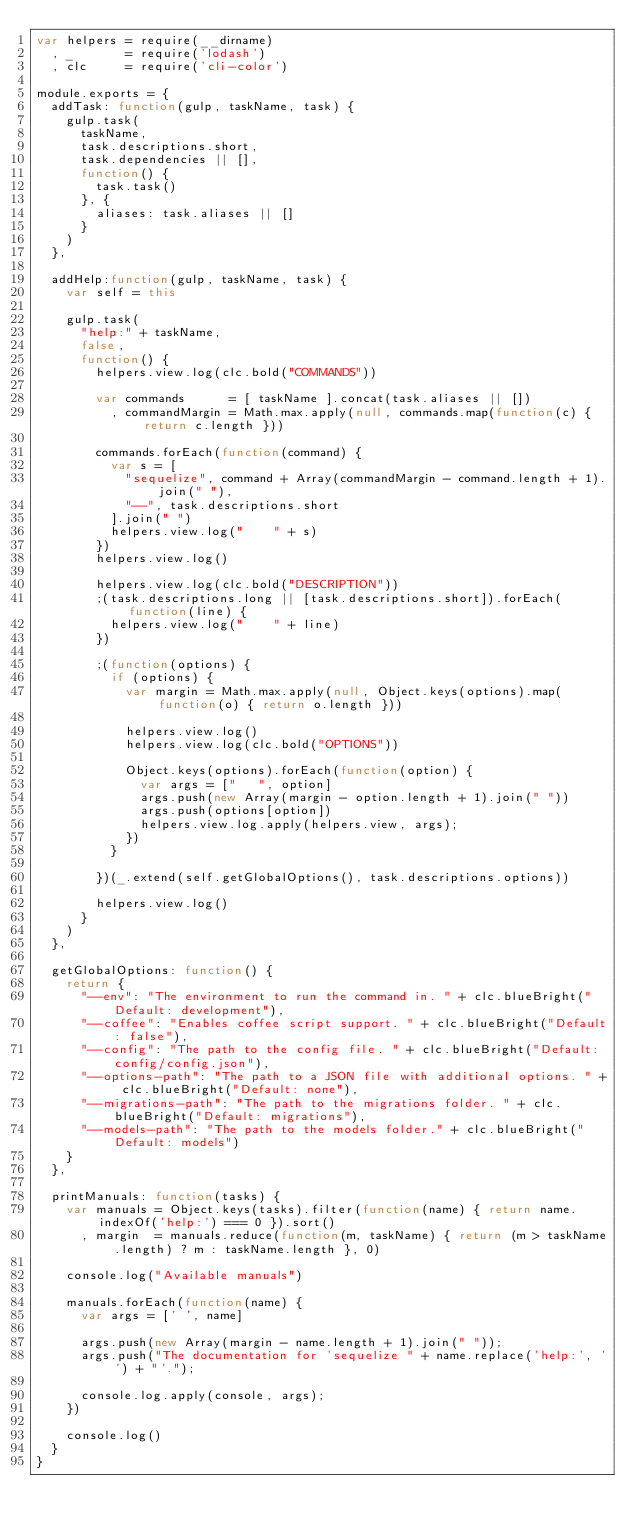Convert code to text. <code><loc_0><loc_0><loc_500><loc_500><_JavaScript_>var helpers = require(__dirname)
  , _       = require('lodash')
  , clc     = require('cli-color')

module.exports = {
  addTask: function(gulp, taskName, task) {
    gulp.task(
      taskName,
      task.descriptions.short,
      task.dependencies || [],
      function() {
        task.task()
      }, {
        aliases: task.aliases || []
      }
    )
  },

  addHelp:function(gulp, taskName, task) {
    var self = this

    gulp.task(
      "help:" + taskName,
      false,
      function() {
        helpers.view.log(clc.bold("COMMANDS"))

        var commands      = [ taskName ].concat(task.aliases || [])
          , commandMargin = Math.max.apply(null, commands.map(function(c) { return c.length }))

        commands.forEach(function(command) {
          var s = [
            "sequelize", command + Array(commandMargin - command.length + 1).join(" "),
            "--", task.descriptions.short
          ].join(" ")
          helpers.view.log("    " + s)
        })
        helpers.view.log()

        helpers.view.log(clc.bold("DESCRIPTION"))
        ;(task.descriptions.long || [task.descriptions.short]).forEach(function(line) {
          helpers.view.log("    " + line)
        })

        ;(function(options) {
          if (options) {
            var margin = Math.max.apply(null, Object.keys(options).map(function(o) { return o.length }))

            helpers.view.log()
            helpers.view.log(clc.bold("OPTIONS"))

            Object.keys(options).forEach(function(option) {
              var args = ["   ", option]
              args.push(new Array(margin - option.length + 1).join(" "))
              args.push(options[option])
              helpers.view.log.apply(helpers.view, args);
            })
          }

        })(_.extend(self.getGlobalOptions(), task.descriptions.options))

        helpers.view.log()
      }
    )
  },

  getGlobalOptions: function() {
    return {
      "--env": "The environment to run the command in. " + clc.blueBright("Default: development"),
      "--coffee": "Enables coffee script support. " + clc.blueBright("Default: false"),
      "--config": "The path to the config file. " + clc.blueBright("Default: config/config.json"),
      "--options-path": "The path to a JSON file with additional options. " + clc.blueBright("Default: none"),
      "--migrations-path": "The path to the migrations folder. " + clc.blueBright("Default: migrations"),
      "--models-path": "The path to the models folder." + clc.blueBright("Default: models")
    }
  },

  printManuals: function(tasks) {
    var manuals = Object.keys(tasks).filter(function(name) { return name.indexOf('help:') === 0 }).sort()
      , margin  = manuals.reduce(function(m, taskName) { return (m > taskName.length) ? m : taskName.length }, 0)

    console.log("Available manuals")

    manuals.forEach(function(name) {
      var args = [' ', name]

      args.push(new Array(margin - name.length + 1).join(" "));
      args.push("The documentation for 'sequelize " + name.replace('help:', '') + "'.");

      console.log.apply(console, args);
    })

    console.log()
  }
}
</code> 